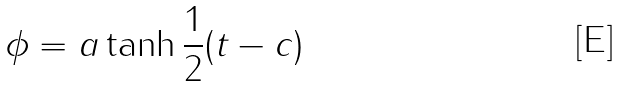<formula> <loc_0><loc_0><loc_500><loc_500>\phi = a \tanh { \frac { 1 } { 2 } ( t - c ) }</formula> 